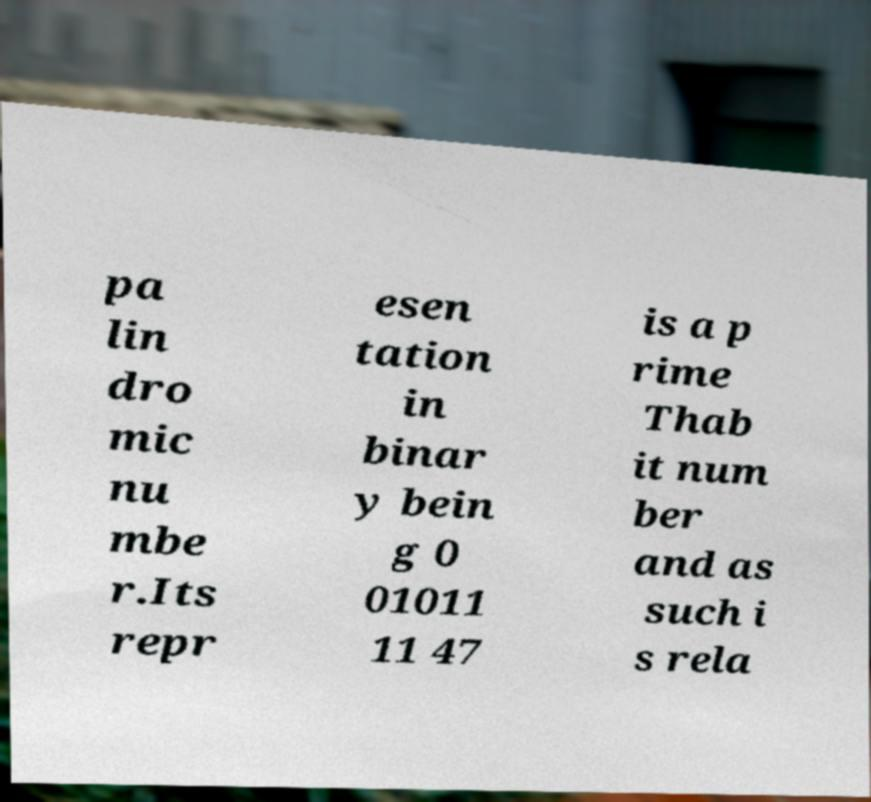Please read and relay the text visible in this image. What does it say? pa lin dro mic nu mbe r.Its repr esen tation in binar y bein g 0 01011 11 47 is a p rime Thab it num ber and as such i s rela 